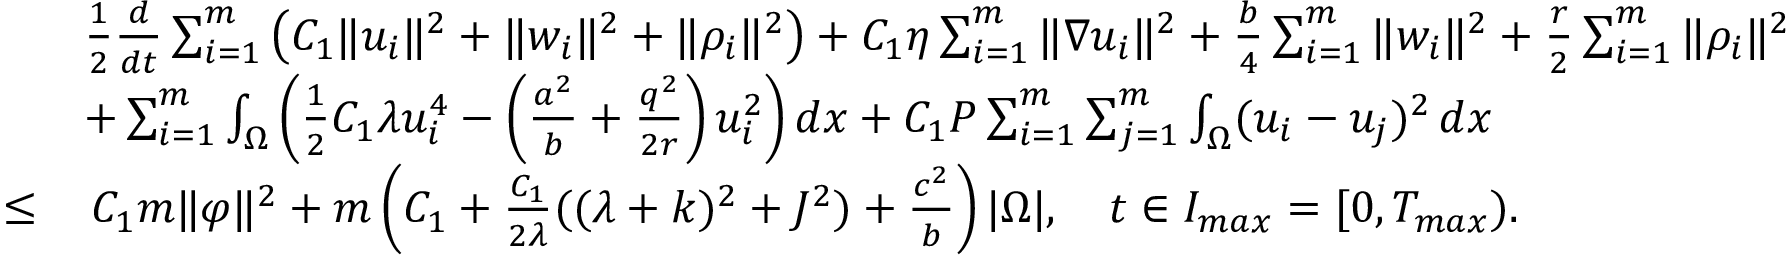<formula> <loc_0><loc_0><loc_500><loc_500>\begin{array} { r l } & { \frac { 1 } { 2 } \frac { d } { d t } \sum _ { i = 1 } ^ { m } \left ( C _ { 1 } \| u _ { i } \| ^ { 2 } + \| w _ { i } \| ^ { 2 } + \| \rho _ { i } \| ^ { 2 } \right ) + C _ { 1 } \eta \sum _ { i = 1 } ^ { m } \| \nabla u _ { i } \| ^ { 2 } + \frac { b } { 4 } \sum _ { i = 1 } ^ { m } \| w _ { i } \| ^ { 2 } + \frac { r } { 2 } \sum _ { i = 1 } ^ { m } \| \rho _ { i } \| ^ { 2 } } \\ & { + \sum _ { i = 1 } ^ { m } \int _ { \Omega } \left ( \frac { 1 } { 2 } C _ { 1 } \lambda u _ { i } ^ { 4 } - \left ( \frac { a ^ { 2 } } { b } + \frac { q ^ { 2 } } { 2 r } \right ) u _ { i } ^ { 2 } \right ) d x + C _ { 1 } P \sum _ { i = 1 } ^ { m } \sum _ { j = 1 } ^ { m } \int _ { \Omega } ( u _ { i } - u _ { j } ) ^ { 2 } \, d x } \\ { \leq } & { \, C _ { 1 } m \| \varphi \| ^ { 2 } + m \left ( C _ { 1 } + \frac { C _ { 1 } } { 2 \lambda } ( ( \lambda + k ) ^ { 2 } + J ^ { 2 } ) + \frac { c ^ { 2 } } { b } \right ) | \Omega | , \quad t \in I _ { \max } = [ 0 , T _ { \max } ) . } \end{array}</formula> 